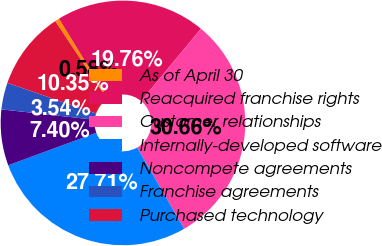Convert chart to OTSL. <chart><loc_0><loc_0><loc_500><loc_500><pie_chart><fcel>As of April 30<fcel>Reacquired franchise rights<fcel>Customer relationships<fcel>Internally-developed software<fcel>Noncompete agreements<fcel>Franchise agreements<fcel>Purchased technology<nl><fcel>0.58%<fcel>19.76%<fcel>30.66%<fcel>27.71%<fcel>7.4%<fcel>3.54%<fcel>10.35%<nl></chart> 